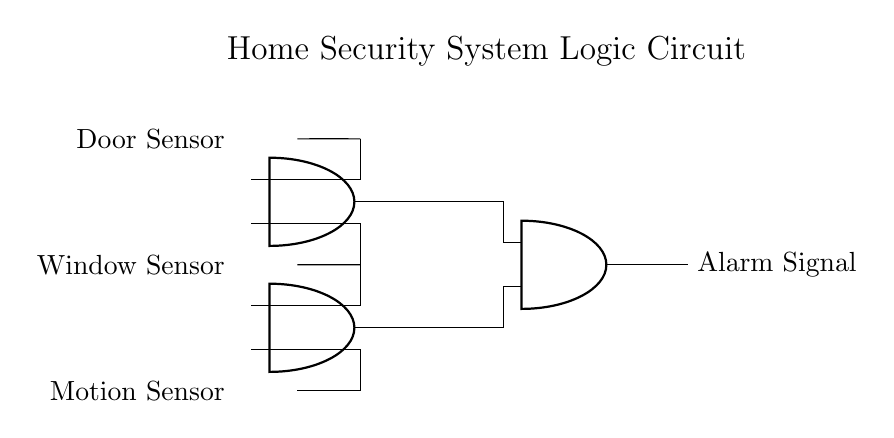What types of sensors are used in this circuit? The circuit includes a Door Sensor, Window Sensor, and Motion Sensor, as indicated by the labels next to the input nodes on the left side.
Answer: Door Sensor, Window Sensor, Motion Sensor How many AND gates are present in the circuit? There are three AND gates indicated by the symbols on the right side of the circuit. The circuit layout shows these components clearly with their respective connections.
Answer: Three What is the output of the circuit? The output, labeled next to the rightmost component, is an Alarm Signal, which indicates activation of the security system when all sensors trigger.
Answer: Alarm Signal What inputs are required for the third AND gate to activate? The third AND gate requires the outputs from the first and second AND gates, as shown by the lines connecting them to the inputs of this gate.
Answer: Two outputs If the Door Sensor and Motion Sensor are triggered, what will the output be? The output will depend on whether the Window Sensor is also triggered. Since the first AND gate requires both the Door and Window Sensors to be active, without the latter, the output cannot be activated.
Answer: No output What is the role of the first AND gate in this circuit? The first AND gate processes the inputs from the Door Sensor and Window Sensor. The output from this gate becomes an input for the third AND gate, contributing to the overall alarm signal when activated.
Answer: Input processing Which components are connected to the output of the second AND gate? The output of the second AND gate is connected to the third AND gate, indicating that its activation requires both it and the first AND gate to trigger the alarm signal.
Answer: The third AND gate 